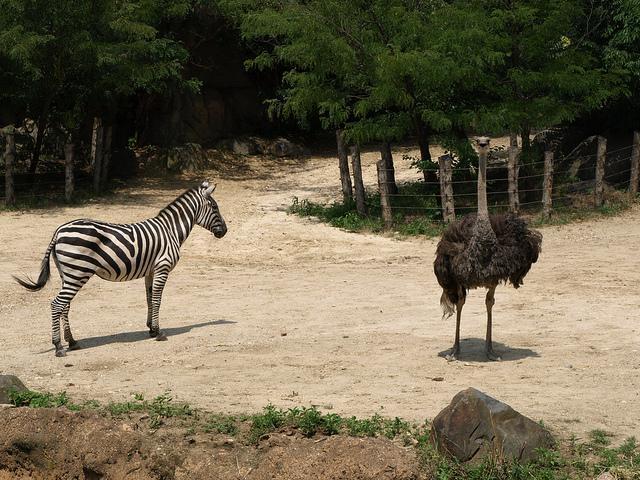How many boulders are in front of the ostrich?
Give a very brief answer. 1. How many people wears a brown tie?
Give a very brief answer. 0. 